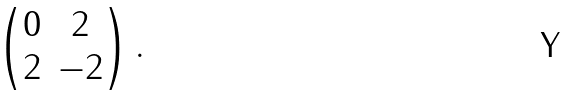Convert formula to latex. <formula><loc_0><loc_0><loc_500><loc_500>\begin{pmatrix} 0 & 2 \\ 2 & - 2 \end{pmatrix} .</formula> 